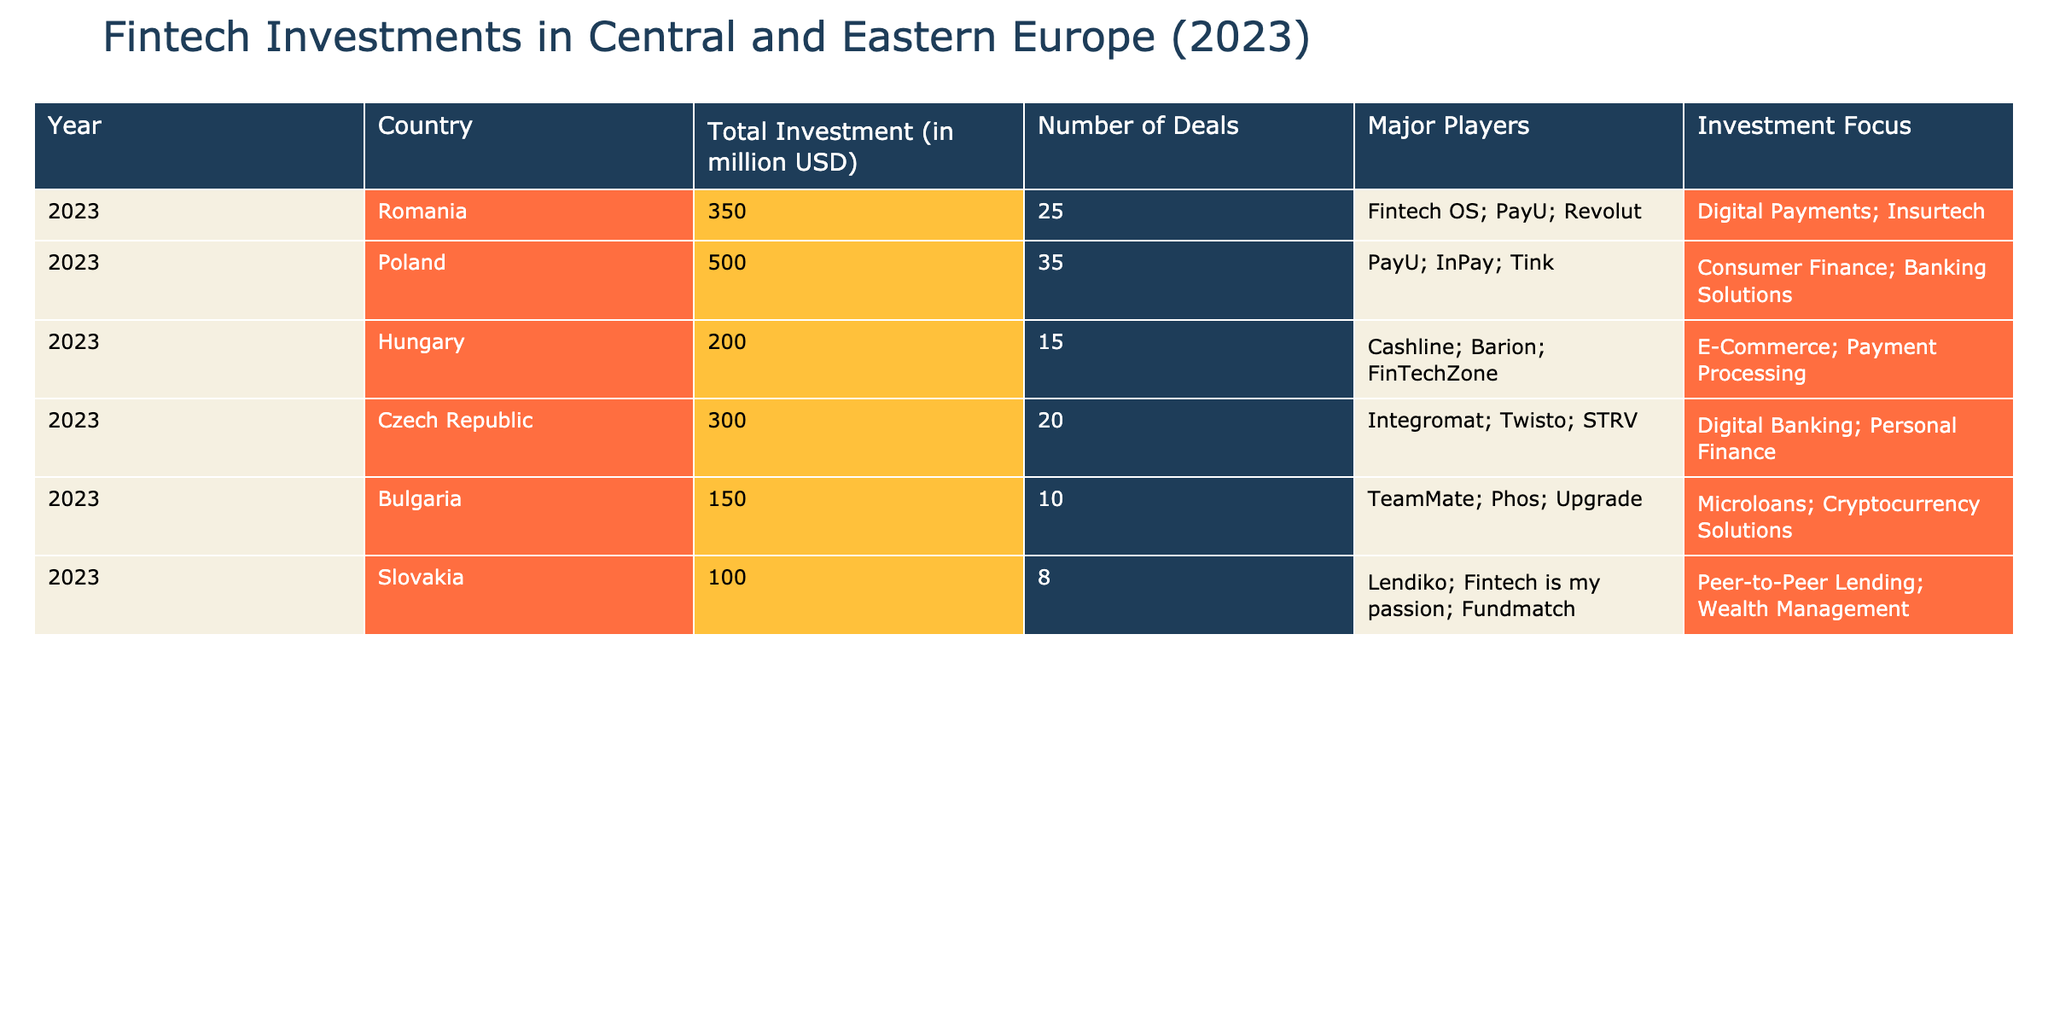What was the total investment in Romania for fintech in 2023? The table shows that the total investment in Romania for 2023 is listed as 350 million USD.
Answer: 350 million USD Which country had the highest number of deals in fintech investments in 2023? According to the table, Poland had the highest number of deals with 35, compared to other countries.
Answer: Poland What is the combined total investment for Hungary and Bulgaria in fintech in 2023? Hungary had a total investment of 200 million USD and Bulgaria 150 million USD. Adding these gives 200 + 150 = 350 million USD.
Answer: 350 million USD Was the major player PayU involved in fintech investments in more than one country in 2023? Yes, PayU is listed as a major player in both Romania and Poland, which confirms it was involved in multiple countries.
Answer: Yes What was the average total investment across all listed countries in the table for 2023? First, sum the total investments: 350 + 500 + 200 + 300 + 150 + 100 = 1600 million USD. There are 6 countries, so the average is 1600 / 6 = 266.67 million USD.
Answer: 266.67 million USD Which country has the lowest total investment amount in the fintech sector for 2023? The table shows that Slovakia has the lowest total investment at 100 million USD, indicating it received the least funding among the listed countries.
Answer: Slovakia Are any of the major players focused on Cryptocurrency Solutions in Bulgaria? Yes, "Upgrade" is mentioned as a major player in Bulgaria and it focuses on Cryptocurrency Solutions.
Answer: Yes How many deals were recorded in total for Poland and the Czech Republic combined? Poland had 35 deals and the Czech Republic had 20 deals; adding these gives 35 + 20 = 55 total deals.
Answer: 55 deals What investment focus is shared by Romania and Czech Republic in 2023? Both Romania and the Czech Republic have "Digital Payments" and "Digital Banking" in their investment focus areas.
Answer: Digital Payments and Digital Banking 